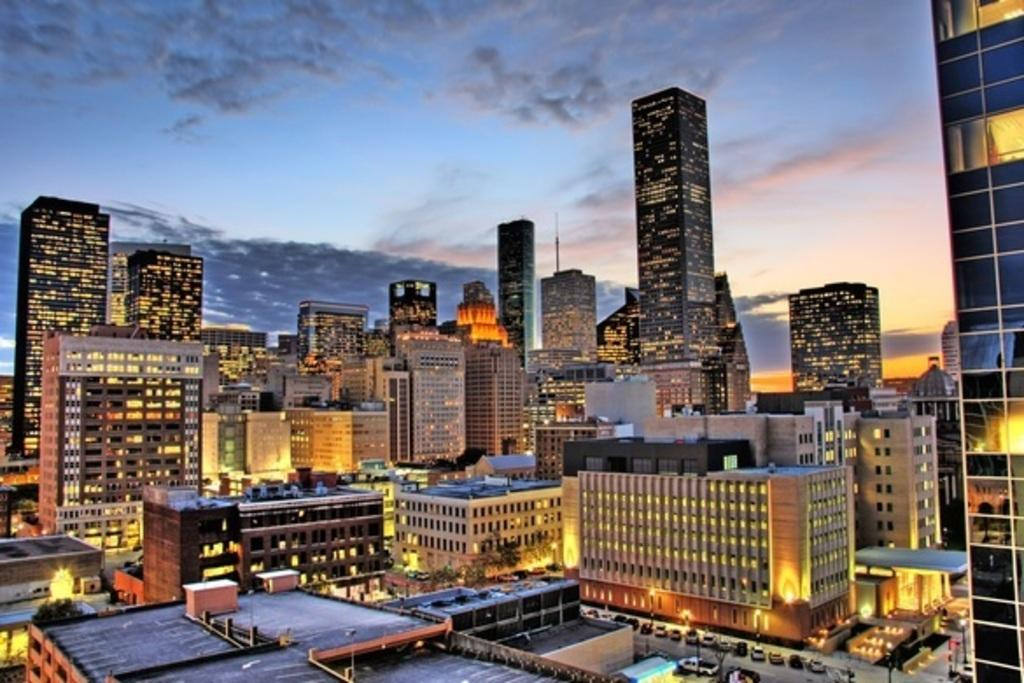What type of structures can be seen in the image? There are buildings in the image. What mode of transportation is visible on the road in the image? There are cars on the road in the image. What type of vegetation is present in the image? There are trees in the image. What can be seen in the background of the image? The sky is visible in the background of the image. What is the condition of the sky in the image? Clouds are present in the sky. Can you tell me how many farmers are working in the fields in the image? There are no farmers present in the image; it features buildings, cars, trees, and a sky with clouds. What type of maid is visible in the image? There is no maid present in the image. 